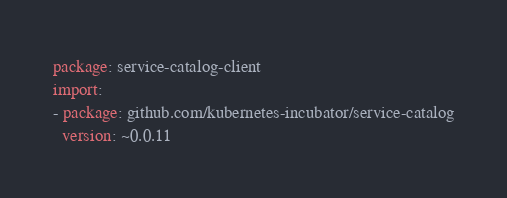<code> <loc_0><loc_0><loc_500><loc_500><_YAML_>package: service-catalog-client
import:
- package: github.com/kubernetes-incubator/service-catalog
  version: ~0.0.11
</code> 